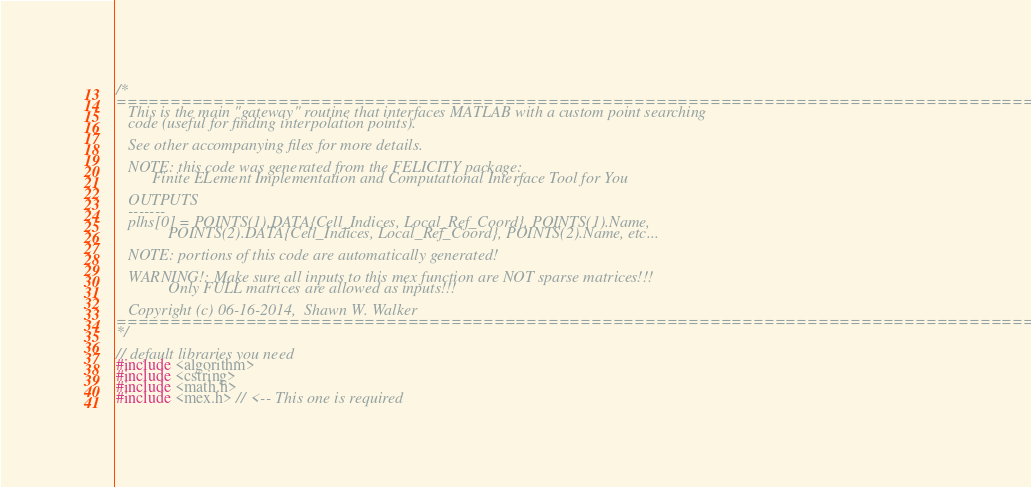<code> <loc_0><loc_0><loc_500><loc_500><_C++_>/*
============================================================================================
   This is the main "gateway" routine that interfaces MATLAB with a custom point searching
   code (useful for finding interpolation points).

   See other accompanying files for more details.

   NOTE: this code was generated from the FELICITY package:
         Finite ELement Implementation and Computational Interface Tool for You

   OUTPUTS
   -------
   plhs[0] = POINTS(1).DATA{Cell_Indices, Local_Ref_Coord}, POINTS(1).Name,
             POINTS(2).DATA{Cell_Indices, Local_Ref_Coord}, POINTS(2).Name, etc...

   NOTE: portions of this code are automatically generated!

   WARNING!: Make sure all inputs to this mex function are NOT sparse matrices!!!
             Only FULL matrices are allowed as inputs!!!

   Copyright (c) 06-16-2014,  Shawn W. Walker
============================================================================================
*/

// default libraries you need
#include <algorithm>
#include <cstring>
#include <math.h>
#include <mex.h> // <-- This one is required

</code> 